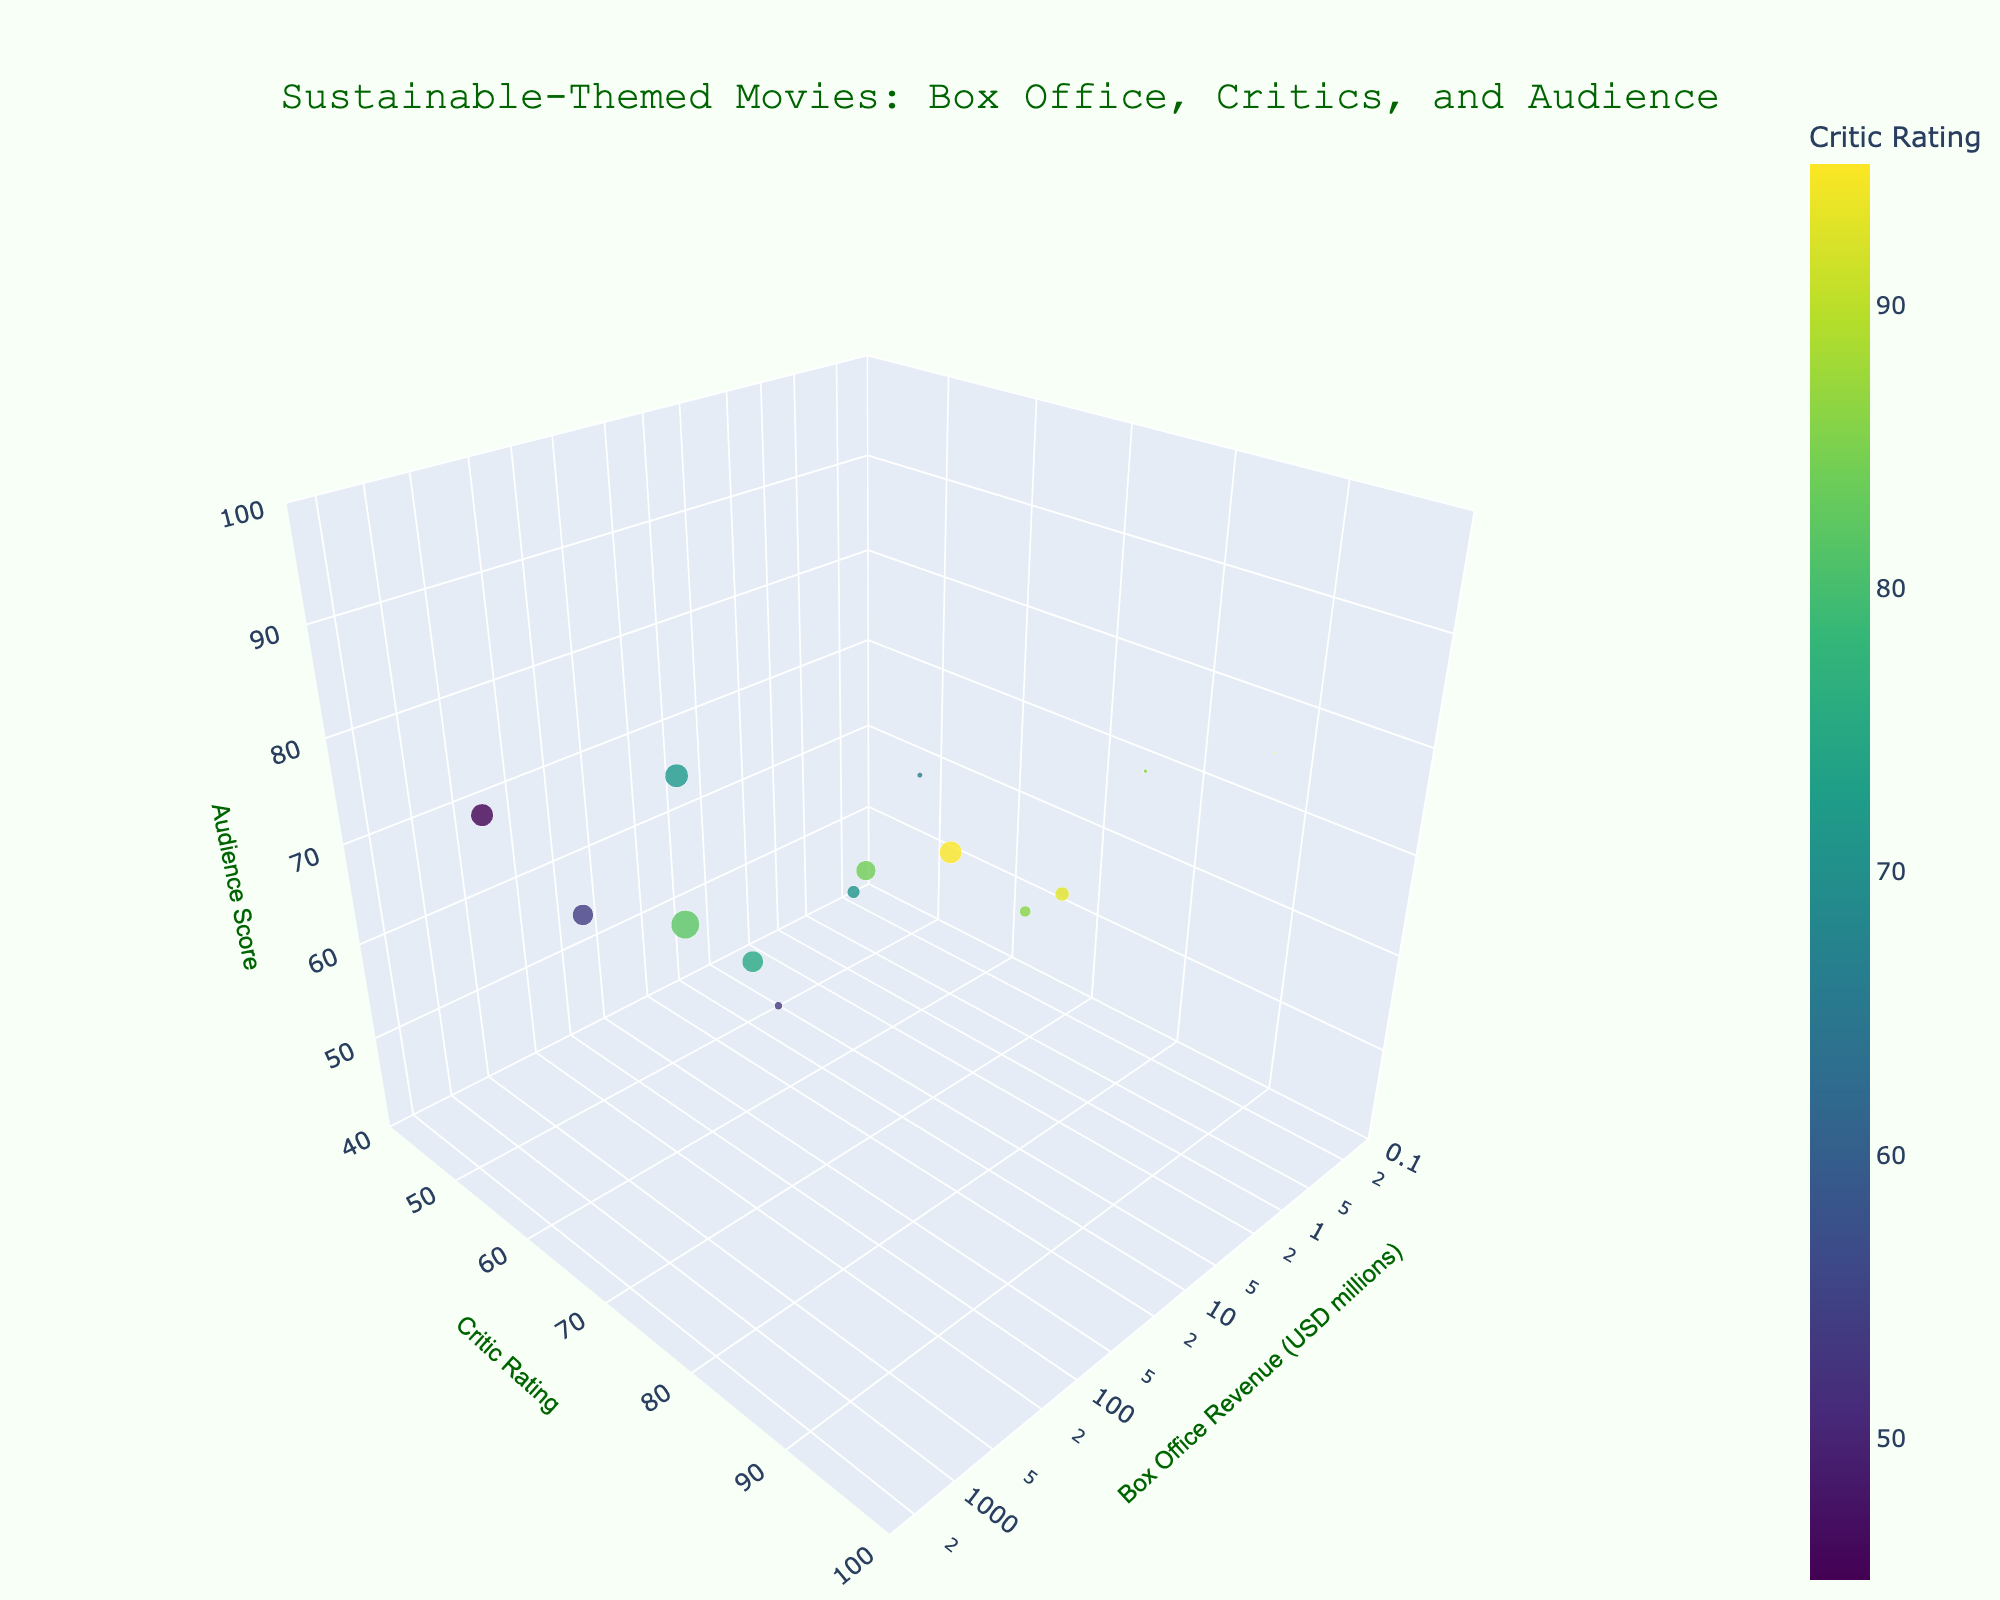What is the title of the plot? The title of the plot is stated at the top-center of the figure. It should be easily visible in a larger font, indicating the main theme of the visualization.
Answer: Sustainable-Themed Movies: Box Office, Critics, and Audience How many movies are plotted on the 3D scatter plot? Count the total number of points (markers) on the scatter plot. Each point corresponds to a movie title from the dataset.
Answer: 15 Which movie has the highest box office revenue, and what is its audience score? Locate the data point farthest to the right on the Box Office Revenue axis, then check its position on the Audience Score axis. Hover over it or refer to the provided data to identify the movie.
Answer: Avatar, 82 Which movie received the highest critic rating, and what is its box office revenue? Identify the data point positioned highest on the Critic Rating axis, then check its position on the Box Office Revenue axis. Hover over it or refer to the provided data to identify the movie.
Answer: Wall-E, 521.3 million USD What is the average audience score for movies with a box office revenue greater than 500 million USD? Identify the movies with box office revenues greater than 500 million by their positions on the Box Office Revenue axis. Then find the average of their Audience Scores. The qualifying movies are Interstellar, Wall-E, and The Day After Tomorrow. Their audience scores are (86 + 89 + 71) / 3 = 82.
Answer: 82 Which movie has the highest audience score, and what are its critic rating and box office revenue? Locate the data point highest on the Audience Score axis to identify the movie. Then, check its positions on the Critic Rating and Box Office Revenue axes.
Answer: Wall-E, 95, 521.3 million USD Do movies with higher critic ratings generally have higher audience scores? Assess the distribution of data points by aligning their positions on the Critic Ratings and Audience Scores axes. Determine if there's a visible positive correlation between the two axes.
Answer: Yes Which movie has the lowest box office revenue, and what is its audience score? Locate the data point closest to the origin on the Box Office Revenue axis. Check its position on the Audience Score axis and hover over it or refer to the provided data to identify the movie.
Answer: Cowspiracy, 89 What is the range of the Critic Rating axis? Examine the layout settings of the figure, specifically the y-axis settings, to determine the range set for Critic Ratings.
Answer: 40 to 100 Which movie with a box office revenue under 10 million USD received the highest critic rating? Identify movies with box office revenues under 10 million by their positions on the Box Office Revenue axis. Among these, find the one highest on the Critic Rating axis.
Answer: The Cove 